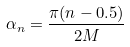Convert formula to latex. <formula><loc_0><loc_0><loc_500><loc_500>\alpha _ { n } = \frac { \pi ( n - 0 . 5 ) } { 2 M }</formula> 